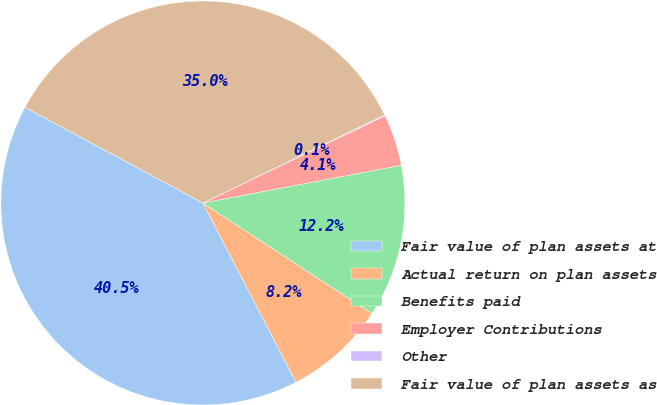Convert chart to OTSL. <chart><loc_0><loc_0><loc_500><loc_500><pie_chart><fcel>Fair value of plan assets at<fcel>Actual return on plan assets<fcel>Benefits paid<fcel>Employer Contributions<fcel>Other<fcel>Fair value of plan assets as<nl><fcel>40.49%<fcel>8.16%<fcel>12.2%<fcel>4.12%<fcel>0.07%<fcel>34.96%<nl></chart> 